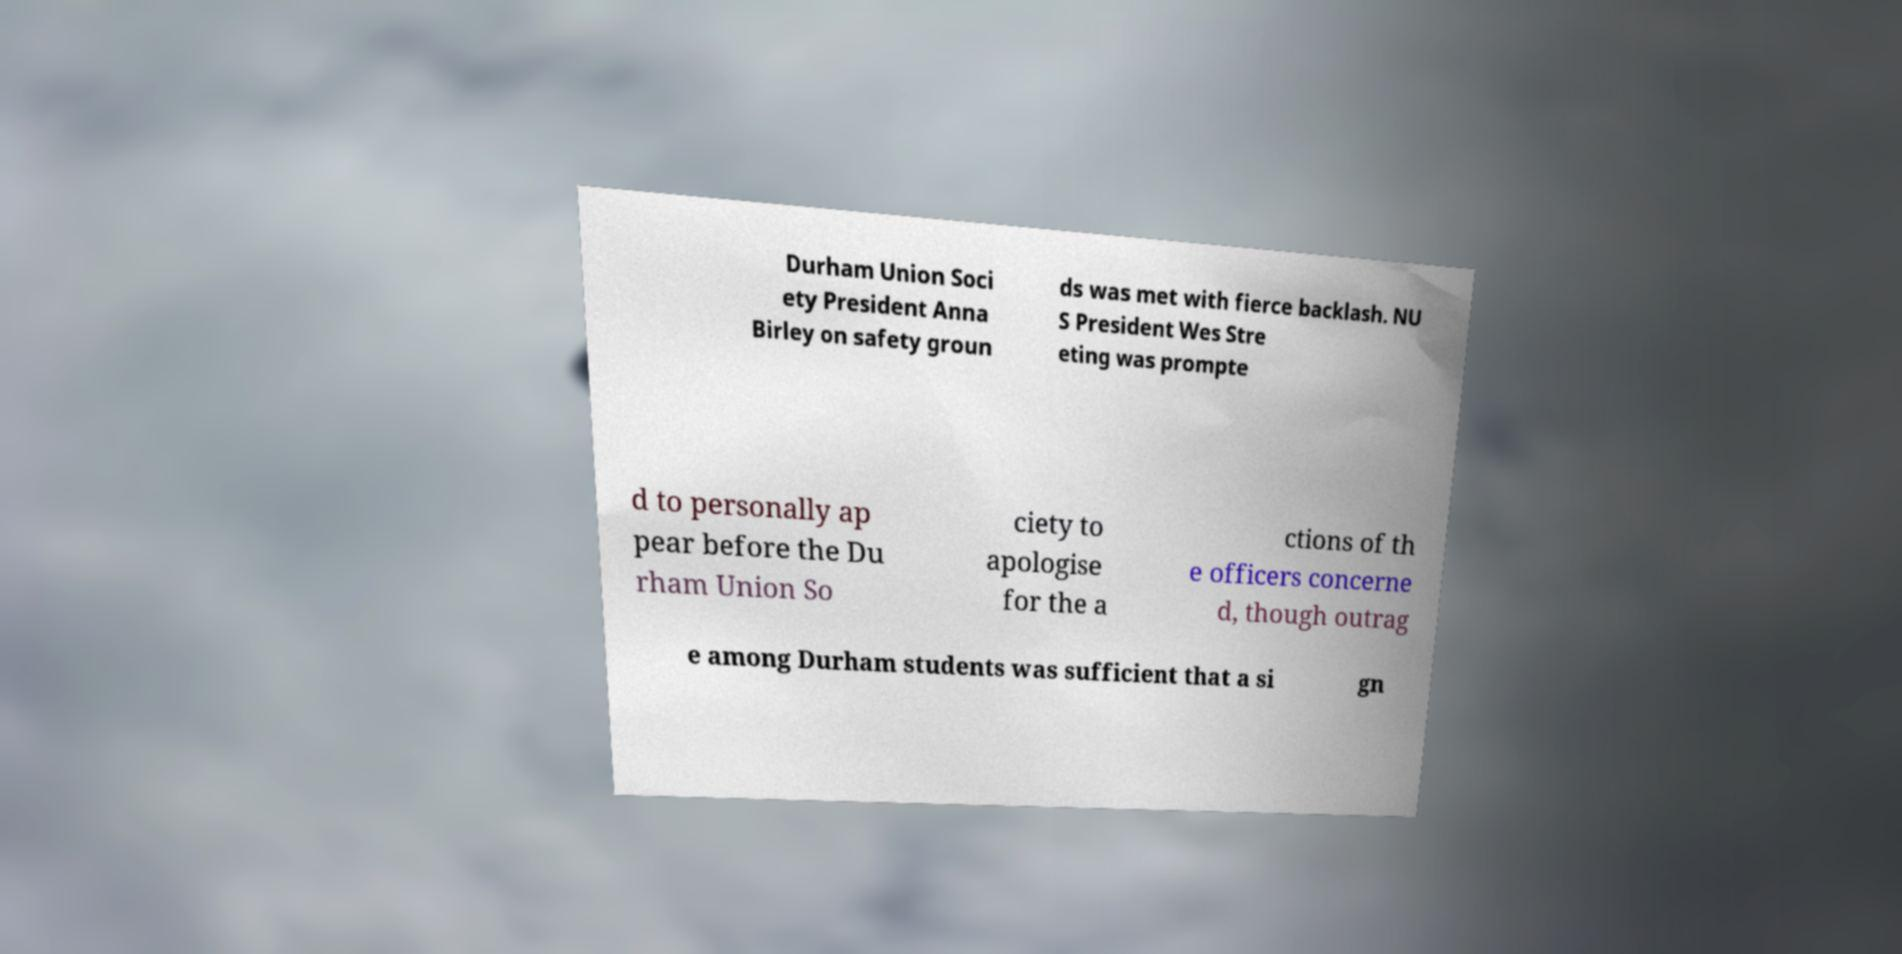Please identify and transcribe the text found in this image. Durham Union Soci ety President Anna Birley on safety groun ds was met with fierce backlash. NU S President Wes Stre eting was prompte d to personally ap pear before the Du rham Union So ciety to apologise for the a ctions of th e officers concerne d, though outrag e among Durham students was sufficient that a si gn 